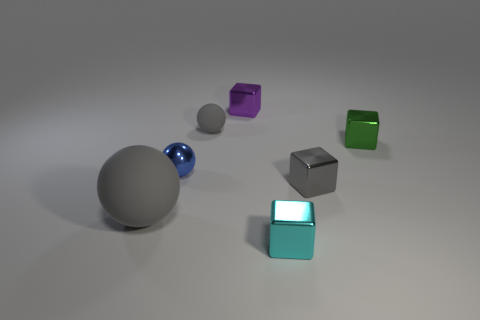Is the color of the matte thing that is behind the large sphere the same as the shiny ball?
Ensure brevity in your answer.  No. What is the size of the matte ball that is behind the green thing?
Your response must be concise. Small. What is the shape of the shiny thing that is on the left side of the tiny block behind the green object?
Your answer should be very brief. Sphere. The large thing that is the same shape as the tiny blue thing is what color?
Your answer should be very brief. Gray. Does the gray rubber sphere behind the blue shiny ball have the same size as the large thing?
Offer a terse response. No. What shape is the shiny thing that is the same color as the large sphere?
Your answer should be very brief. Cube. What number of small cyan things have the same material as the green block?
Provide a short and direct response. 1. What material is the small object that is in front of the small gray thing that is in front of the matte object behind the small green thing?
Provide a succinct answer. Metal. What color is the tiny metal thing in front of the gray block in front of the shiny ball?
Provide a short and direct response. Cyan. There is a shiny ball that is the same size as the purple cube; what is its color?
Ensure brevity in your answer.  Blue. 